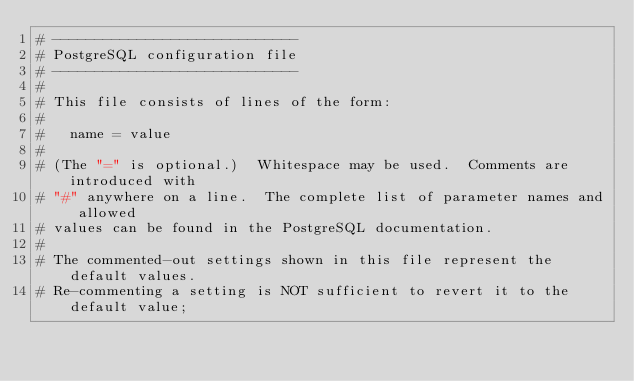<code> <loc_0><loc_0><loc_500><loc_500><_ObjectiveC_># -----------------------------
# PostgreSQL configuration file
# -----------------------------
#
# This file consists of lines of the form:
#
#   name = value
#
# (The "=" is optional.)  Whitespace may be used.  Comments are introduced with
# "#" anywhere on a line.  The complete list of parameter names and allowed
# values can be found in the PostgreSQL documentation.
#
# The commented-out settings shown in this file represent the default values.
# Re-commenting a setting is NOT sufficient to revert it to the default value;</code> 